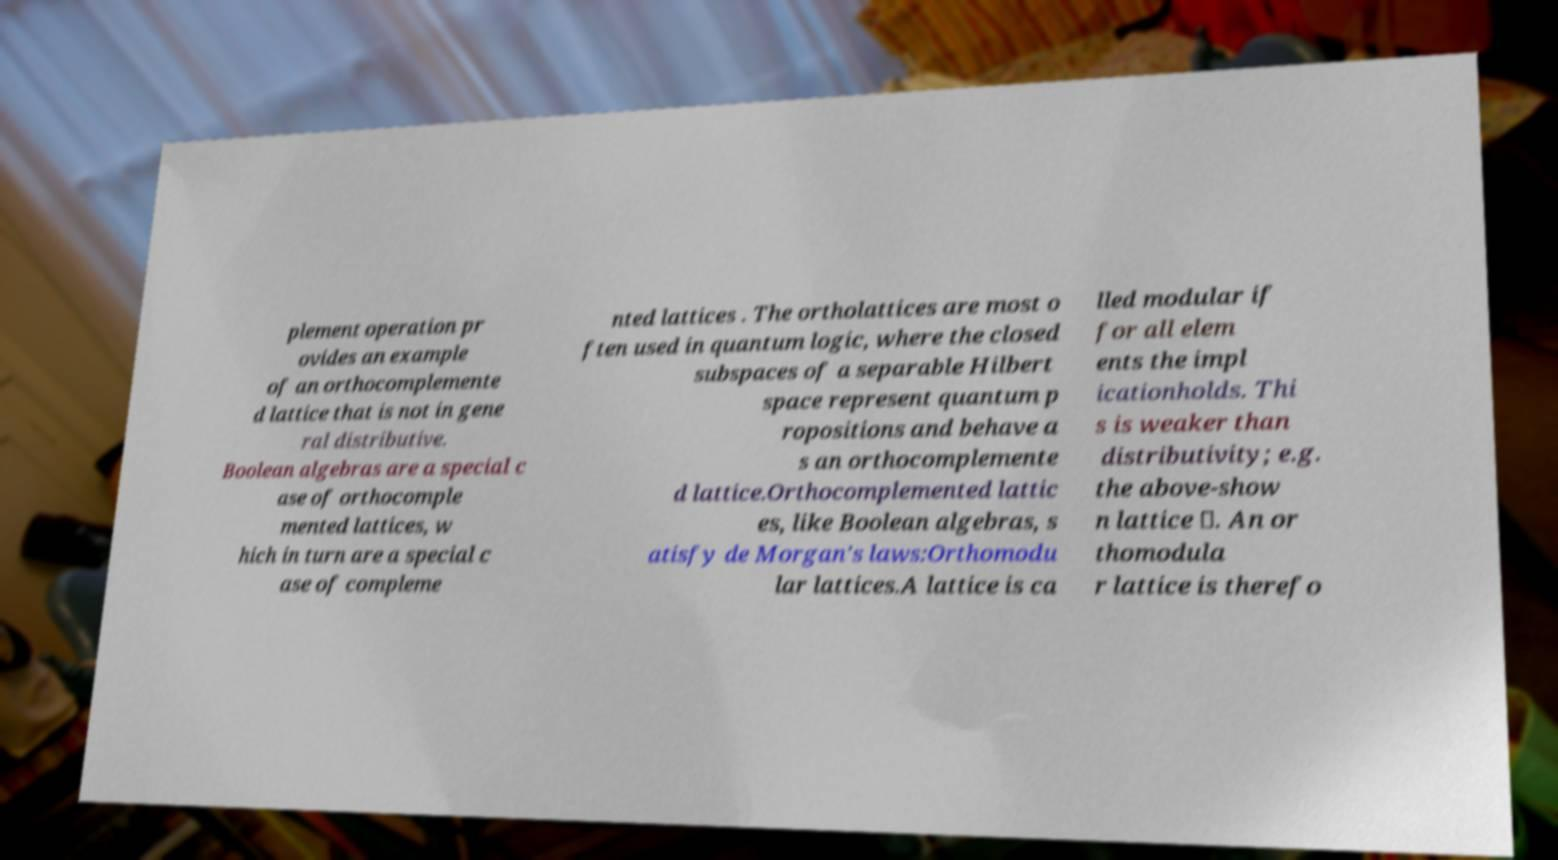Please identify and transcribe the text found in this image. plement operation pr ovides an example of an orthocomplemente d lattice that is not in gene ral distributive. Boolean algebras are a special c ase of orthocomple mented lattices, w hich in turn are a special c ase of compleme nted lattices . The ortholattices are most o ften used in quantum logic, where the closed subspaces of a separable Hilbert space represent quantum p ropositions and behave a s an orthocomplemente d lattice.Orthocomplemented lattic es, like Boolean algebras, s atisfy de Morgan's laws:Orthomodu lar lattices.A lattice is ca lled modular if for all elem ents the impl icationholds. Thi s is weaker than distributivity; e.g. the above-show n lattice ⊥. An or thomodula r lattice is therefo 